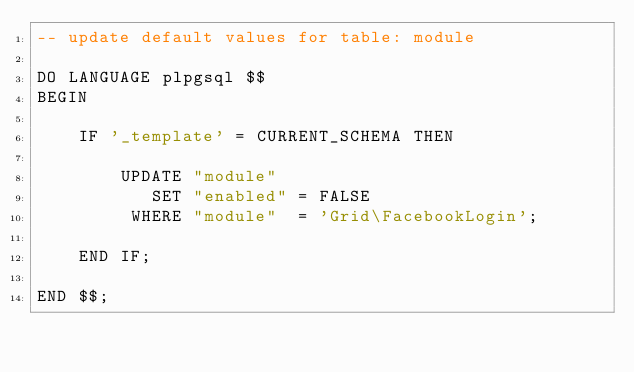<code> <loc_0><loc_0><loc_500><loc_500><_SQL_>-- update default values for table: module

DO LANGUAGE plpgsql $$
BEGIN

    IF '_template' = CURRENT_SCHEMA THEN

        UPDATE "module"
           SET "enabled" = FALSE
         WHERE "module"  = 'Grid\FacebookLogin';

    END IF;

END $$;
</code> 